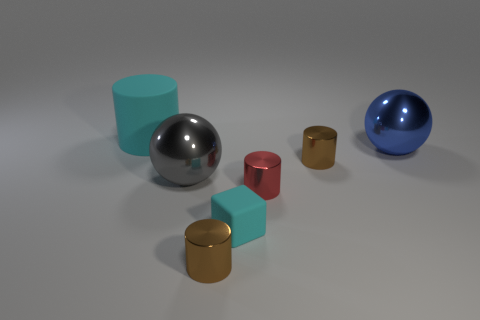What is the shape of the other object that is the same color as the tiny matte thing?
Offer a very short reply. Cylinder. Are there any cyan things made of the same material as the blue thing?
Your answer should be compact. No. Is the material of the cyan thing that is on the right side of the big cylinder the same as the small object that is in front of the cube?
Your response must be concise. No. Are there an equal number of tiny red metallic cylinders that are behind the rubber cylinder and tiny cyan things that are in front of the cyan block?
Your answer should be compact. Yes. There is a rubber cube that is the same size as the red thing; what is its color?
Ensure brevity in your answer.  Cyan. Is there a small object that has the same color as the small rubber cube?
Ensure brevity in your answer.  No. How many things are either things in front of the tiny matte cube or gray things?
Provide a succinct answer. 2. What number of other things are there of the same size as the matte block?
Your response must be concise. 3. There is a large gray thing behind the cyan object in front of the cyan rubber thing behind the tiny block; what is it made of?
Keep it short and to the point. Metal. How many cylinders are matte objects or small rubber things?
Provide a succinct answer. 1. 